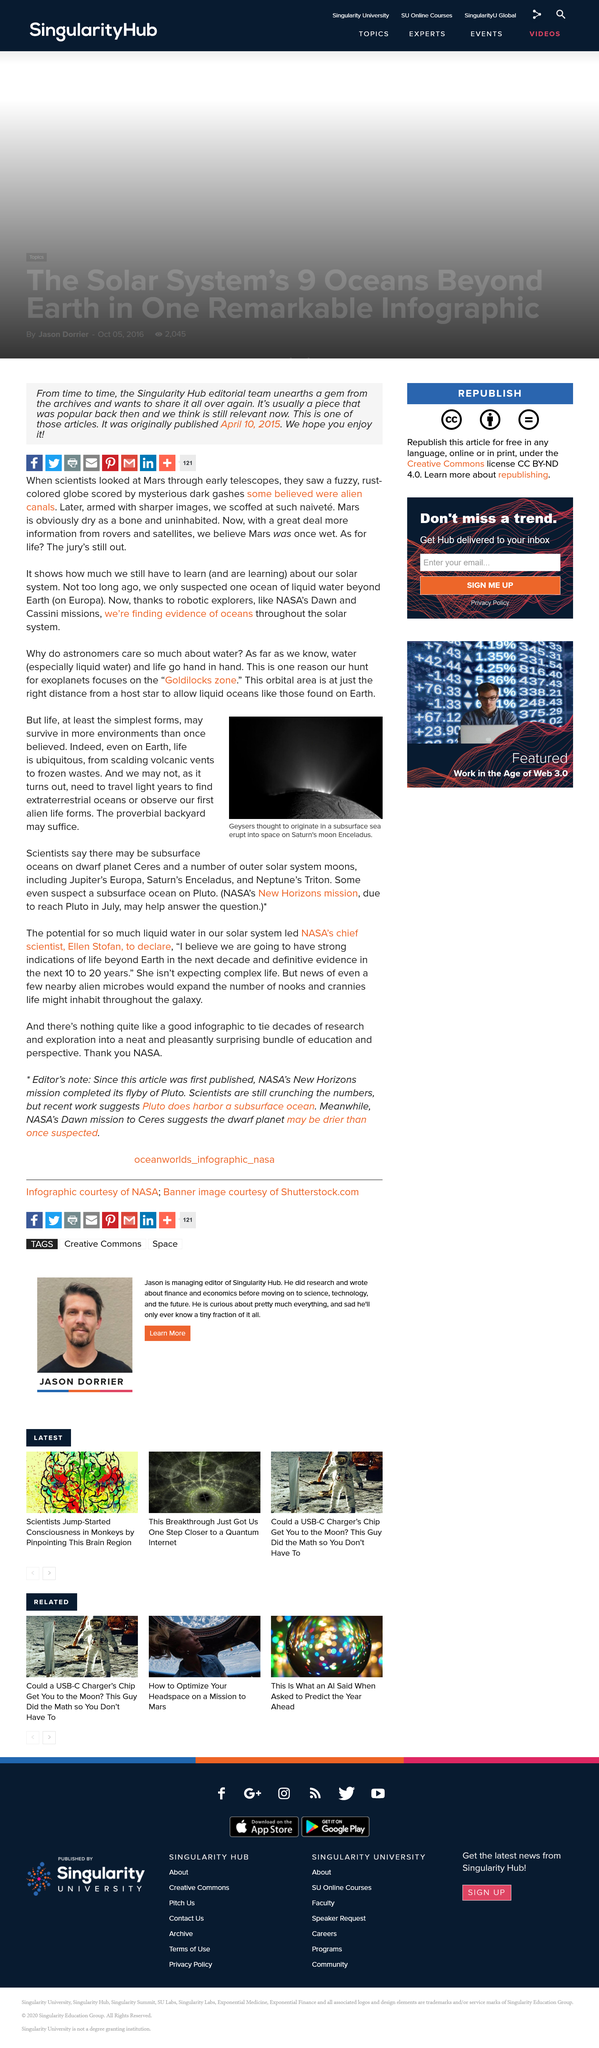List a handful of essential elements in this visual. The image portrays Saturn's moon Enceladus. NASA's New Horizons mission is scheduled to reach Pluto on July. Scientists have discovered that Ceres, the largest asteroid in the asteroid belt between Mars and Jupiter, may have subsurface oceans. 